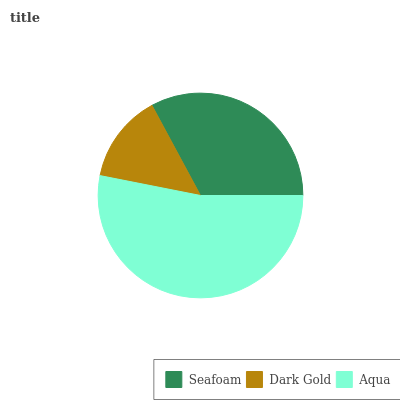Is Dark Gold the minimum?
Answer yes or no. Yes. Is Aqua the maximum?
Answer yes or no. Yes. Is Aqua the minimum?
Answer yes or no. No. Is Dark Gold the maximum?
Answer yes or no. No. Is Aqua greater than Dark Gold?
Answer yes or no. Yes. Is Dark Gold less than Aqua?
Answer yes or no. Yes. Is Dark Gold greater than Aqua?
Answer yes or no. No. Is Aqua less than Dark Gold?
Answer yes or no. No. Is Seafoam the high median?
Answer yes or no. Yes. Is Seafoam the low median?
Answer yes or no. Yes. Is Aqua the high median?
Answer yes or no. No. Is Dark Gold the low median?
Answer yes or no. No. 